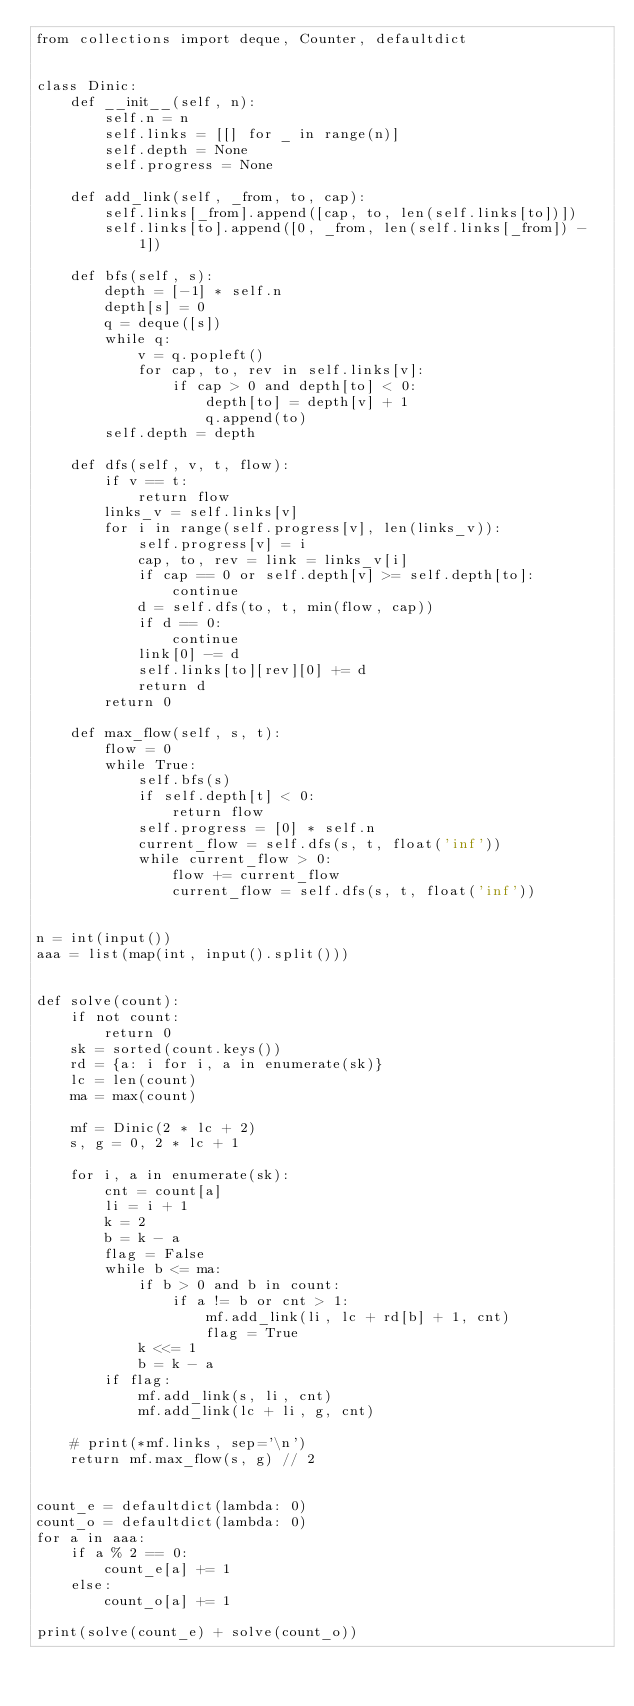Convert code to text. <code><loc_0><loc_0><loc_500><loc_500><_Python_>from collections import deque, Counter, defaultdict


class Dinic:
    def __init__(self, n):
        self.n = n
        self.links = [[] for _ in range(n)]
        self.depth = None
        self.progress = None

    def add_link(self, _from, to, cap):
        self.links[_from].append([cap, to, len(self.links[to])])
        self.links[to].append([0, _from, len(self.links[_from]) - 1])

    def bfs(self, s):
        depth = [-1] * self.n
        depth[s] = 0
        q = deque([s])
        while q:
            v = q.popleft()
            for cap, to, rev in self.links[v]:
                if cap > 0 and depth[to] < 0:
                    depth[to] = depth[v] + 1
                    q.append(to)
        self.depth = depth

    def dfs(self, v, t, flow):
        if v == t:
            return flow
        links_v = self.links[v]
        for i in range(self.progress[v], len(links_v)):
            self.progress[v] = i
            cap, to, rev = link = links_v[i]
            if cap == 0 or self.depth[v] >= self.depth[to]:
                continue
            d = self.dfs(to, t, min(flow, cap))
            if d == 0:
                continue
            link[0] -= d
            self.links[to][rev][0] += d
            return d
        return 0

    def max_flow(self, s, t):
        flow = 0
        while True:
            self.bfs(s)
            if self.depth[t] < 0:
                return flow
            self.progress = [0] * self.n
            current_flow = self.dfs(s, t, float('inf'))
            while current_flow > 0:
                flow += current_flow
                current_flow = self.dfs(s, t, float('inf'))


n = int(input())
aaa = list(map(int, input().split()))


def solve(count):
    if not count:
        return 0
    sk = sorted(count.keys())
    rd = {a: i for i, a in enumerate(sk)}
    lc = len(count)
    ma = max(count)

    mf = Dinic(2 * lc + 2)
    s, g = 0, 2 * lc + 1

    for i, a in enumerate(sk):
        cnt = count[a]
        li = i + 1
        k = 2
        b = k - a
        flag = False
        while b <= ma:
            if b > 0 and b in count:
                if a != b or cnt > 1:
                    mf.add_link(li, lc + rd[b] + 1, cnt)
                    flag = True
            k <<= 1
            b = k - a
        if flag:
            mf.add_link(s, li, cnt)
            mf.add_link(lc + li, g, cnt)

    # print(*mf.links, sep='\n')
    return mf.max_flow(s, g) // 2


count_e = defaultdict(lambda: 0)
count_o = defaultdict(lambda: 0)
for a in aaa:
    if a % 2 == 0:
        count_e[a] += 1
    else:
        count_o[a] += 1

print(solve(count_e) + solve(count_o))
</code> 